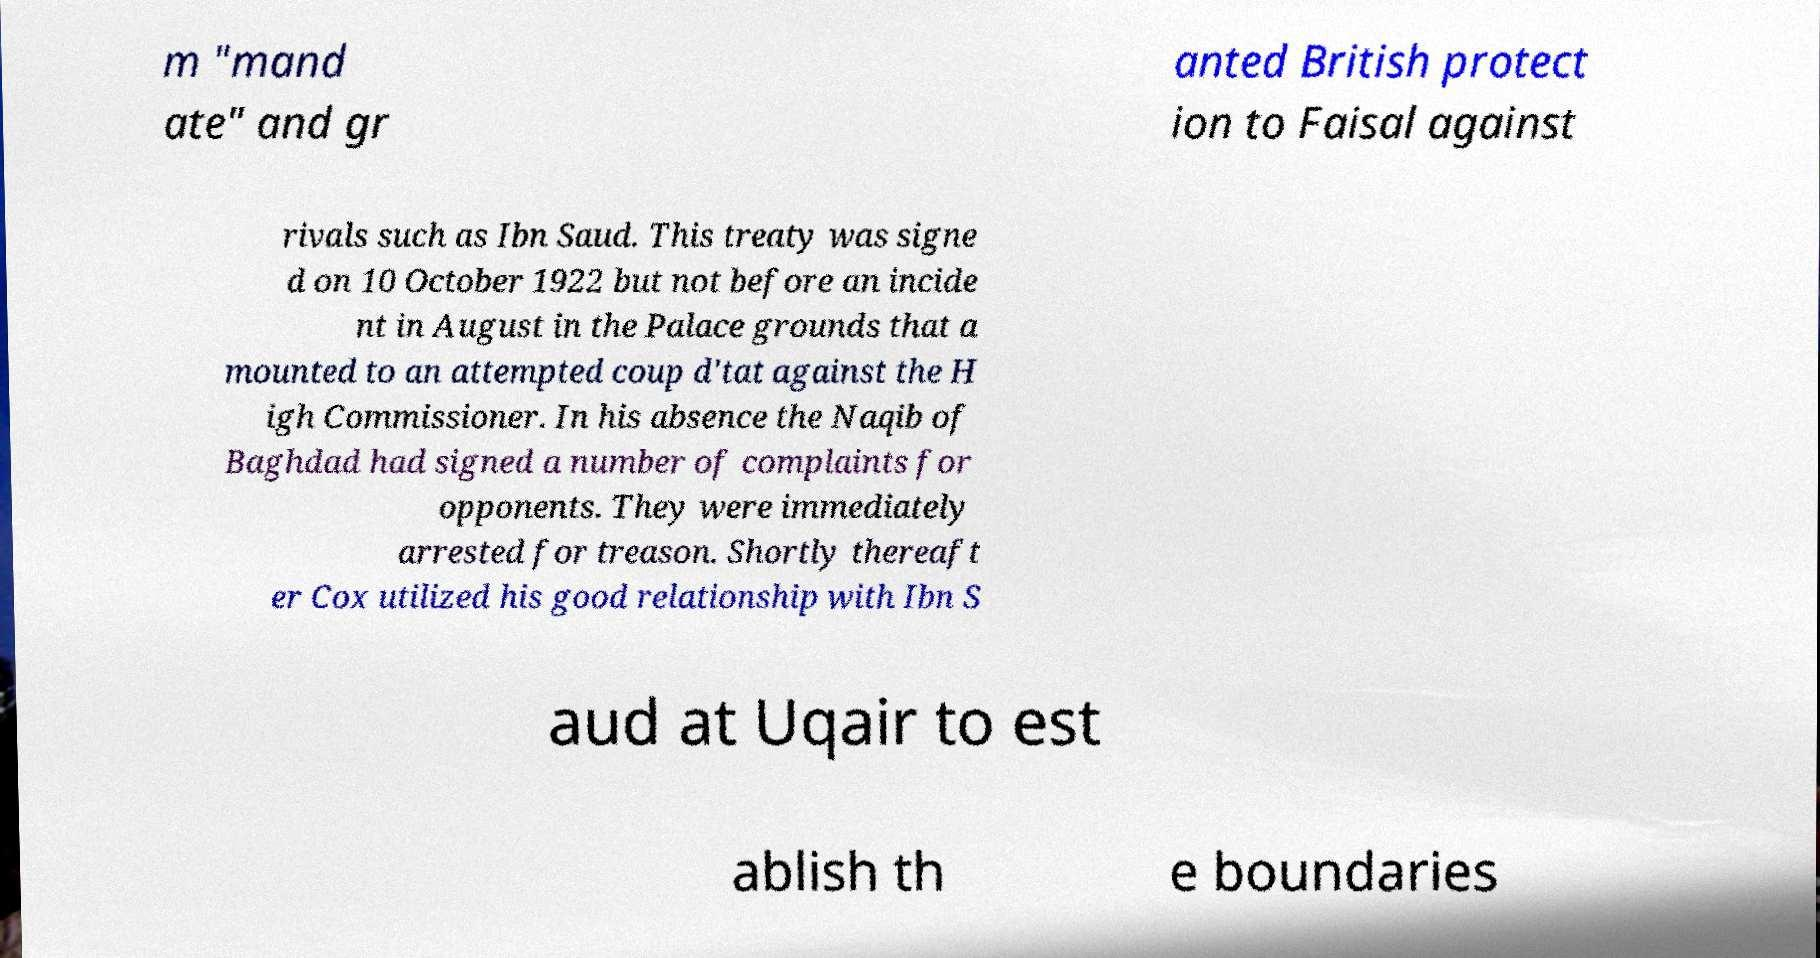I need the written content from this picture converted into text. Can you do that? m "mand ate" and gr anted British protect ion to Faisal against rivals such as Ibn Saud. This treaty was signe d on 10 October 1922 but not before an incide nt in August in the Palace grounds that a mounted to an attempted coup d'tat against the H igh Commissioner. In his absence the Naqib of Baghdad had signed a number of complaints for opponents. They were immediately arrested for treason. Shortly thereaft er Cox utilized his good relationship with Ibn S aud at Uqair to est ablish th e boundaries 